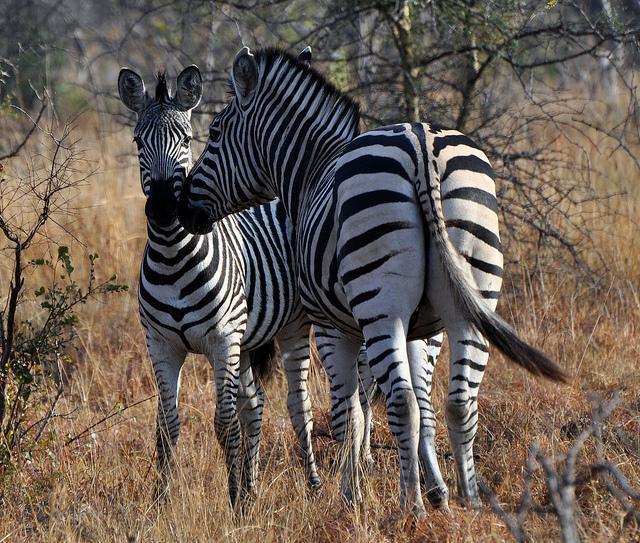How many zebra are standing together?
Give a very brief answer. 2. How many zebras are in the picture?
Give a very brief answer. 2. How many zebras are in the foreground?
Give a very brief answer. 2. How many zebras are there?
Give a very brief answer. 2. How many zebras can be seen?
Give a very brief answer. 2. 